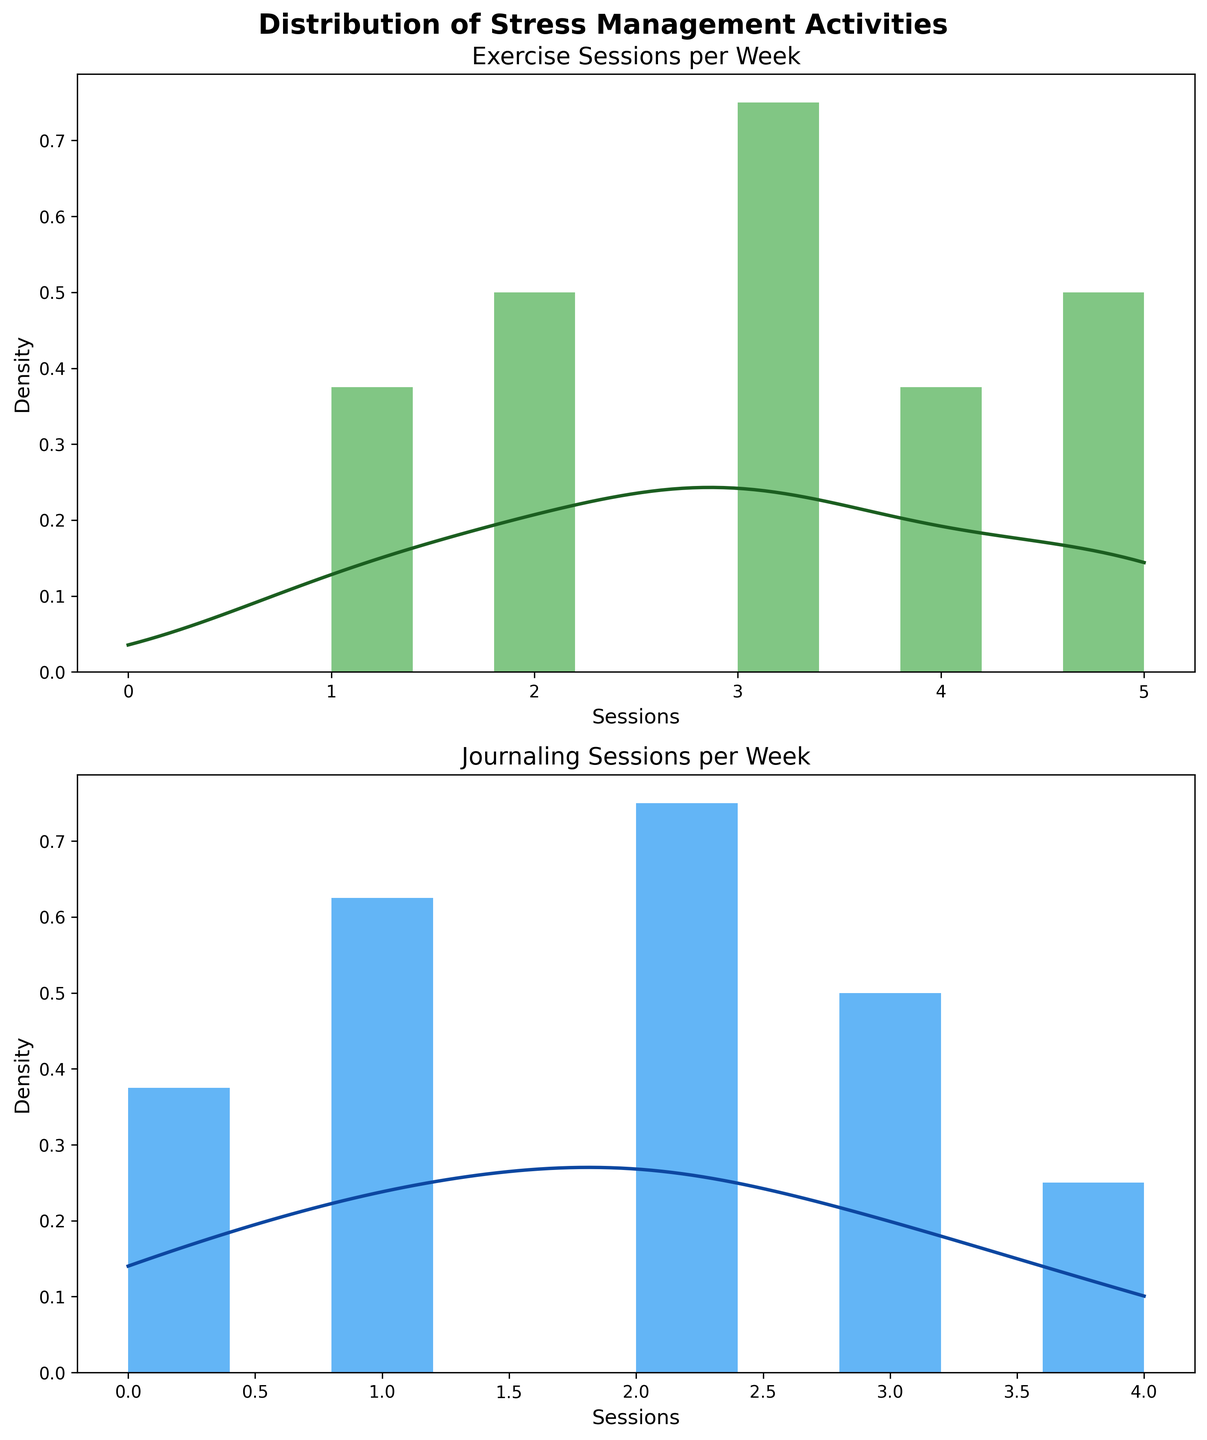What is the title of the first plot? The title is displayed at the top of the first plot.
Answer: Exercise Sessions per Week What color represents the histogram bars for journaling sessions? The color of the histogram bars for journaling sessions can be observed directly from the plot.
Answer: Blue How many exercise sessions per week have the highest density? By examining the peak of the KDE curve on the exercise plot, we can see where the highest density occurs.
Answer: 3 sessions What is the range of exercise sessions per week shown in the plot? The x-axis of the exercise sessions plot shows the minimum and maximum values of the sessions per week.
Answer: 0 to 5 sessions Compare the highest density points between exercise and journaling sessions. Which one has a higher value? Identify the highest density points on both KDE curves and compare their y-values.
Answer: Journaling sessions What is the average number of journaling sessions per week? To find the average, sum up all the journaling sessions per week and divide by the number of workers. Calculate (2+1+4+0+3+0+2+1+3+4+2+1+2+3+1+2+3+0+1+2)/20.
Answer: 2 sessions Are there any workers with zero journaling sessions per week? Check the x-axis of the journaling plot and look for bars at the '0' mark.
Answer: Yes What is the spread of the distribution in exercise sessions? The spread can be observed by the width of the x-axis in the exercise plot, which ranges from the minimum to the maximum value of sessions.
Answer: 0 to 5 sessions Does any worker have the same number of exercise and journaling sessions per week? Compare the two datasets to find matching values. For example, worker 1 has 3 exercise sessions and 2 journaling sessions, look for such matches.
Answer: No Which activity, exercise or journaling, has a more concentrated distribution? A more concentrated distribution can be identified by a sharper peak in the KDE curve. Compare the sharpness or narrowness of peaks in both plots.
Answer: Exercise 